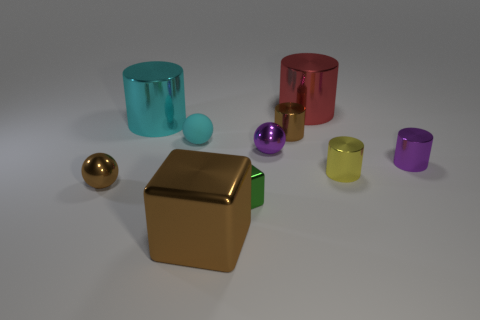Subtract all small shiny spheres. How many spheres are left? 1 Subtract all cyan cylinders. How many cylinders are left? 4 Subtract all cubes. How many objects are left? 8 Subtract 0 gray cylinders. How many objects are left? 10 Subtract all cyan cubes. Subtract all gray balls. How many cubes are left? 2 Subtract all small cyan rubber things. Subtract all yellow metal cylinders. How many objects are left? 8 Add 7 large cylinders. How many large cylinders are left? 9 Add 5 tiny yellow cylinders. How many tiny yellow cylinders exist? 6 